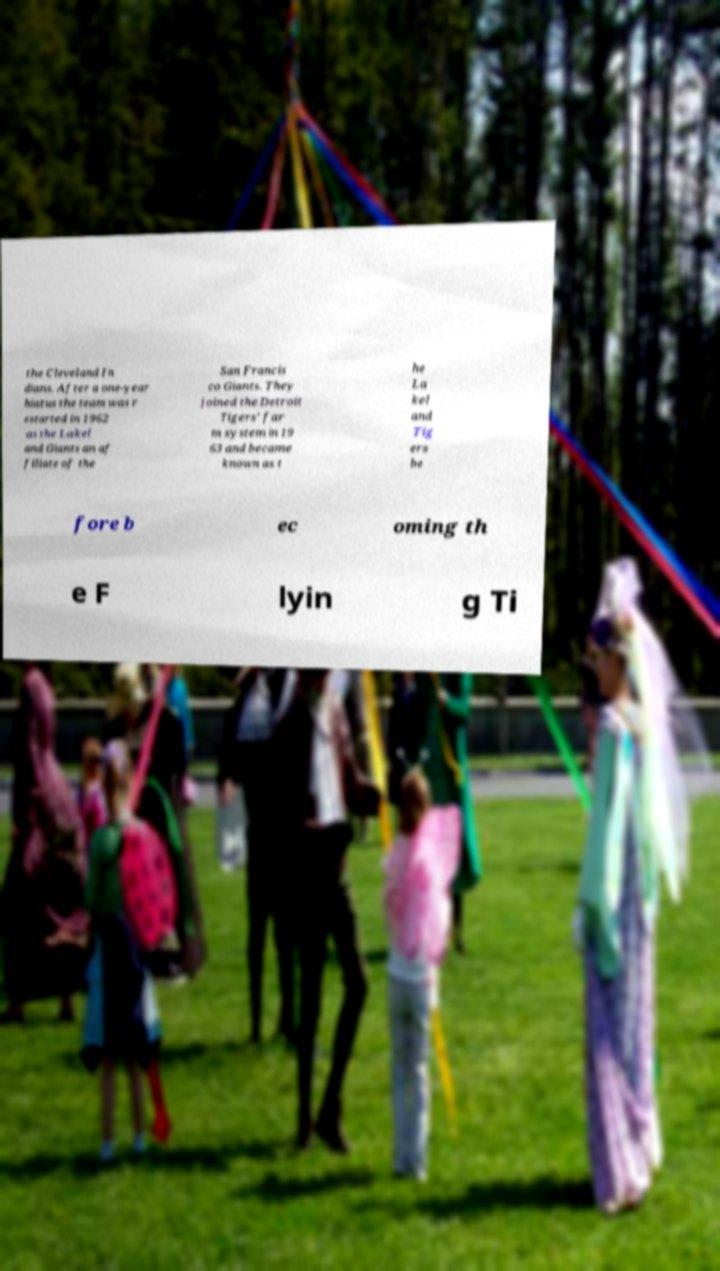Could you extract and type out the text from this image? the Cleveland In dians. After a one-year hiatus the team was r estarted in 1962 as the Lakel and Giants an af filiate of the San Francis co Giants. They joined the Detroit Tigers' far m system in 19 63 and became known as t he La kel and Tig ers be fore b ec oming th e F lyin g Ti 